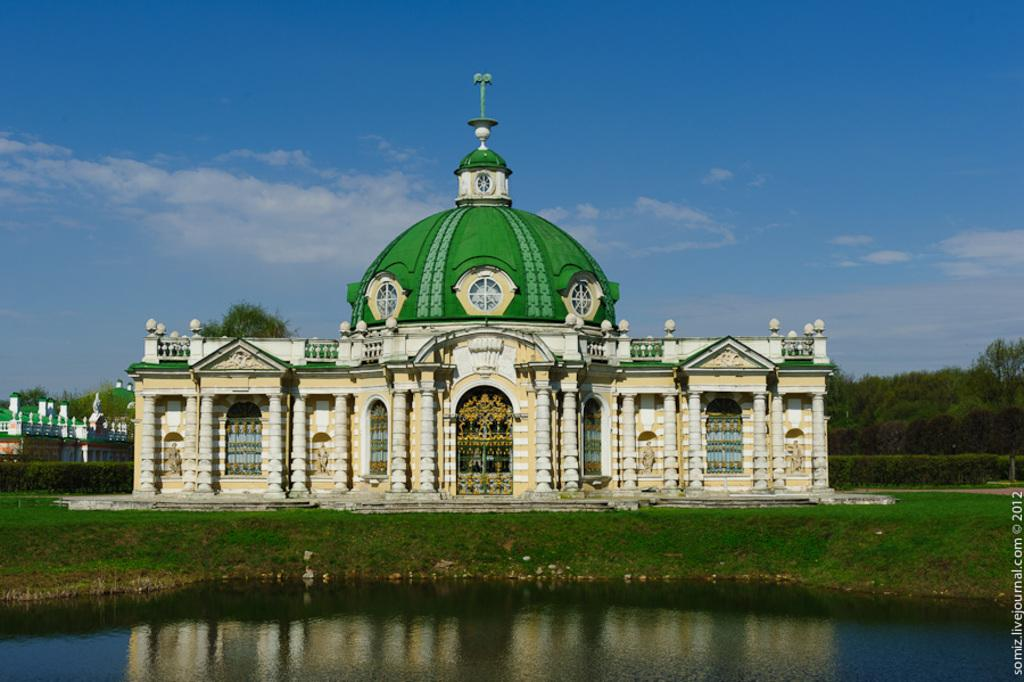What type of building is in the image? There is a yellow mosque in the image. What color is the dome of the mosque? The mosque has a green dome. What is located in front of the mosque? There is a small pond in front of the mosque. What can be seen in the background of the image? There are trees visible in the background of the image. What is visible in the sky in the image? The sky is visible in the image, and clouds are present. What type of record is being played near the mosque in the image? There is no record or any indication of music playing in the image; it features a yellow mosque with a green dome, a small pond, trees in the background, and a sky with clouds. 